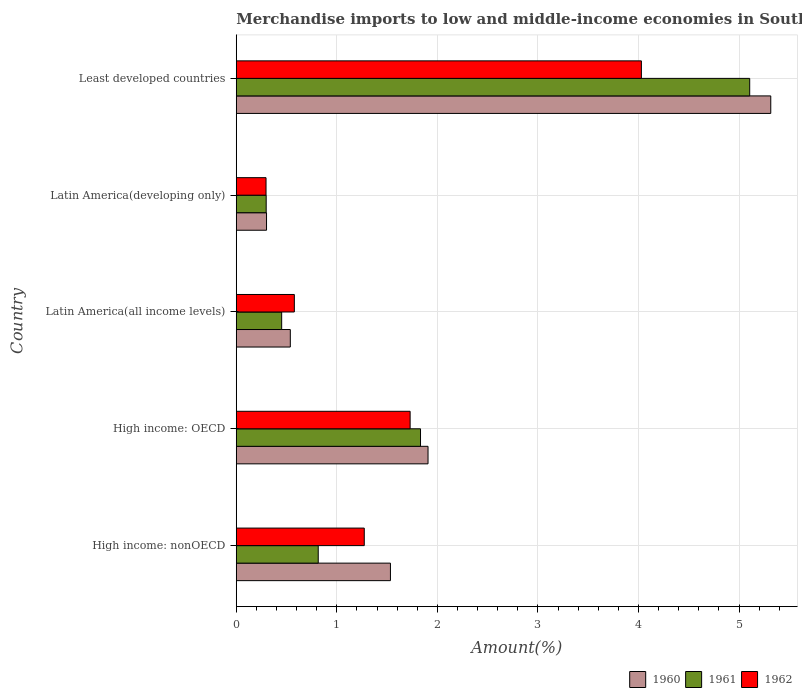How many different coloured bars are there?
Your answer should be compact. 3. Are the number of bars per tick equal to the number of legend labels?
Offer a very short reply. Yes. Are the number of bars on each tick of the Y-axis equal?
Ensure brevity in your answer.  Yes. What is the label of the 1st group of bars from the top?
Make the answer very short. Least developed countries. In how many cases, is the number of bars for a given country not equal to the number of legend labels?
Your response must be concise. 0. What is the percentage of amount earned from merchandise imports in 1961 in Least developed countries?
Provide a succinct answer. 5.11. Across all countries, what is the maximum percentage of amount earned from merchandise imports in 1961?
Make the answer very short. 5.11. Across all countries, what is the minimum percentage of amount earned from merchandise imports in 1962?
Offer a terse response. 0.3. In which country was the percentage of amount earned from merchandise imports in 1962 maximum?
Your answer should be compact. Least developed countries. In which country was the percentage of amount earned from merchandise imports in 1962 minimum?
Your answer should be very brief. Latin America(developing only). What is the total percentage of amount earned from merchandise imports in 1961 in the graph?
Ensure brevity in your answer.  8.5. What is the difference between the percentage of amount earned from merchandise imports in 1961 in High income: OECD and that in Latin America(developing only)?
Your answer should be compact. 1.53. What is the difference between the percentage of amount earned from merchandise imports in 1962 in High income: OECD and the percentage of amount earned from merchandise imports in 1960 in High income: nonOECD?
Keep it short and to the point. 0.2. What is the average percentage of amount earned from merchandise imports in 1961 per country?
Offer a terse response. 1.7. What is the difference between the percentage of amount earned from merchandise imports in 1962 and percentage of amount earned from merchandise imports in 1961 in High income: OECD?
Offer a terse response. -0.1. In how many countries, is the percentage of amount earned from merchandise imports in 1960 greater than 2.2 %?
Provide a succinct answer. 1. What is the ratio of the percentage of amount earned from merchandise imports in 1961 in High income: OECD to that in Least developed countries?
Your answer should be very brief. 0.36. Is the difference between the percentage of amount earned from merchandise imports in 1962 in High income: nonOECD and Latin America(developing only) greater than the difference between the percentage of amount earned from merchandise imports in 1961 in High income: nonOECD and Latin America(developing only)?
Provide a succinct answer. Yes. What is the difference between the highest and the second highest percentage of amount earned from merchandise imports in 1961?
Ensure brevity in your answer.  3.27. What is the difference between the highest and the lowest percentage of amount earned from merchandise imports in 1960?
Offer a terse response. 5.01. In how many countries, is the percentage of amount earned from merchandise imports in 1960 greater than the average percentage of amount earned from merchandise imports in 1960 taken over all countries?
Provide a short and direct response. 1. Is the sum of the percentage of amount earned from merchandise imports in 1961 in High income: OECD and Least developed countries greater than the maximum percentage of amount earned from merchandise imports in 1962 across all countries?
Offer a terse response. Yes. What does the 3rd bar from the top in Least developed countries represents?
Ensure brevity in your answer.  1960. Is it the case that in every country, the sum of the percentage of amount earned from merchandise imports in 1962 and percentage of amount earned from merchandise imports in 1961 is greater than the percentage of amount earned from merchandise imports in 1960?
Provide a succinct answer. Yes. How many bars are there?
Your answer should be very brief. 15. Are all the bars in the graph horizontal?
Your response must be concise. Yes. What is the difference between two consecutive major ticks on the X-axis?
Ensure brevity in your answer.  1. Are the values on the major ticks of X-axis written in scientific E-notation?
Keep it short and to the point. No. How are the legend labels stacked?
Provide a short and direct response. Horizontal. What is the title of the graph?
Make the answer very short. Merchandise imports to low and middle-income economies in South Asia. What is the label or title of the X-axis?
Your answer should be very brief. Amount(%). What is the label or title of the Y-axis?
Offer a very short reply. Country. What is the Amount(%) of 1960 in High income: nonOECD?
Make the answer very short. 1.53. What is the Amount(%) in 1961 in High income: nonOECD?
Your answer should be compact. 0.82. What is the Amount(%) of 1962 in High income: nonOECD?
Give a very brief answer. 1.27. What is the Amount(%) of 1960 in High income: OECD?
Keep it short and to the point. 1.91. What is the Amount(%) in 1961 in High income: OECD?
Offer a terse response. 1.83. What is the Amount(%) of 1962 in High income: OECD?
Make the answer very short. 1.73. What is the Amount(%) of 1960 in Latin America(all income levels)?
Provide a succinct answer. 0.54. What is the Amount(%) of 1961 in Latin America(all income levels)?
Keep it short and to the point. 0.45. What is the Amount(%) in 1962 in Latin America(all income levels)?
Keep it short and to the point. 0.58. What is the Amount(%) in 1960 in Latin America(developing only)?
Provide a succinct answer. 0.3. What is the Amount(%) in 1961 in Latin America(developing only)?
Provide a succinct answer. 0.3. What is the Amount(%) of 1962 in Latin America(developing only)?
Keep it short and to the point. 0.3. What is the Amount(%) of 1960 in Least developed countries?
Offer a very short reply. 5.32. What is the Amount(%) of 1961 in Least developed countries?
Give a very brief answer. 5.11. What is the Amount(%) of 1962 in Least developed countries?
Keep it short and to the point. 4.03. Across all countries, what is the maximum Amount(%) in 1960?
Offer a terse response. 5.32. Across all countries, what is the maximum Amount(%) in 1961?
Your answer should be compact. 5.11. Across all countries, what is the maximum Amount(%) in 1962?
Your answer should be very brief. 4.03. Across all countries, what is the minimum Amount(%) in 1960?
Your answer should be very brief. 0.3. Across all countries, what is the minimum Amount(%) of 1961?
Make the answer very short. 0.3. Across all countries, what is the minimum Amount(%) in 1962?
Your answer should be compact. 0.3. What is the total Amount(%) in 1960 in the graph?
Your answer should be very brief. 9.59. What is the total Amount(%) in 1961 in the graph?
Provide a succinct answer. 8.5. What is the total Amount(%) of 1962 in the graph?
Provide a succinct answer. 7.9. What is the difference between the Amount(%) of 1960 in High income: nonOECD and that in High income: OECD?
Offer a very short reply. -0.37. What is the difference between the Amount(%) of 1961 in High income: nonOECD and that in High income: OECD?
Ensure brevity in your answer.  -1.02. What is the difference between the Amount(%) of 1962 in High income: nonOECD and that in High income: OECD?
Your response must be concise. -0.46. What is the difference between the Amount(%) in 1961 in High income: nonOECD and that in Latin America(all income levels)?
Provide a short and direct response. 0.36. What is the difference between the Amount(%) in 1962 in High income: nonOECD and that in Latin America(all income levels)?
Your answer should be very brief. 0.7. What is the difference between the Amount(%) in 1960 in High income: nonOECD and that in Latin America(developing only)?
Provide a succinct answer. 1.23. What is the difference between the Amount(%) of 1961 in High income: nonOECD and that in Latin America(developing only)?
Provide a succinct answer. 0.52. What is the difference between the Amount(%) of 1962 in High income: nonOECD and that in Latin America(developing only)?
Offer a terse response. 0.98. What is the difference between the Amount(%) in 1960 in High income: nonOECD and that in Least developed countries?
Offer a terse response. -3.78. What is the difference between the Amount(%) of 1961 in High income: nonOECD and that in Least developed countries?
Your answer should be very brief. -4.29. What is the difference between the Amount(%) in 1962 in High income: nonOECD and that in Least developed countries?
Your answer should be compact. -2.76. What is the difference between the Amount(%) in 1960 in High income: OECD and that in Latin America(all income levels)?
Provide a short and direct response. 1.37. What is the difference between the Amount(%) of 1961 in High income: OECD and that in Latin America(all income levels)?
Your answer should be very brief. 1.38. What is the difference between the Amount(%) in 1962 in High income: OECD and that in Latin America(all income levels)?
Provide a succinct answer. 1.15. What is the difference between the Amount(%) of 1960 in High income: OECD and that in Latin America(developing only)?
Ensure brevity in your answer.  1.61. What is the difference between the Amount(%) in 1961 in High income: OECD and that in Latin America(developing only)?
Ensure brevity in your answer.  1.53. What is the difference between the Amount(%) in 1962 in High income: OECD and that in Latin America(developing only)?
Provide a short and direct response. 1.43. What is the difference between the Amount(%) of 1960 in High income: OECD and that in Least developed countries?
Give a very brief answer. -3.41. What is the difference between the Amount(%) of 1961 in High income: OECD and that in Least developed countries?
Ensure brevity in your answer.  -3.27. What is the difference between the Amount(%) of 1962 in High income: OECD and that in Least developed countries?
Offer a terse response. -2.3. What is the difference between the Amount(%) in 1960 in Latin America(all income levels) and that in Latin America(developing only)?
Offer a terse response. 0.24. What is the difference between the Amount(%) of 1961 in Latin America(all income levels) and that in Latin America(developing only)?
Ensure brevity in your answer.  0.15. What is the difference between the Amount(%) in 1962 in Latin America(all income levels) and that in Latin America(developing only)?
Your response must be concise. 0.28. What is the difference between the Amount(%) in 1960 in Latin America(all income levels) and that in Least developed countries?
Give a very brief answer. -4.78. What is the difference between the Amount(%) of 1961 in Latin America(all income levels) and that in Least developed countries?
Keep it short and to the point. -4.65. What is the difference between the Amount(%) of 1962 in Latin America(all income levels) and that in Least developed countries?
Provide a short and direct response. -3.45. What is the difference between the Amount(%) of 1960 in Latin America(developing only) and that in Least developed countries?
Your answer should be very brief. -5.01. What is the difference between the Amount(%) of 1961 in Latin America(developing only) and that in Least developed countries?
Make the answer very short. -4.81. What is the difference between the Amount(%) in 1962 in Latin America(developing only) and that in Least developed countries?
Your answer should be compact. -3.73. What is the difference between the Amount(%) of 1960 in High income: nonOECD and the Amount(%) of 1961 in High income: OECD?
Offer a very short reply. -0.3. What is the difference between the Amount(%) in 1960 in High income: nonOECD and the Amount(%) in 1962 in High income: OECD?
Give a very brief answer. -0.2. What is the difference between the Amount(%) in 1961 in High income: nonOECD and the Amount(%) in 1962 in High income: OECD?
Your answer should be very brief. -0.91. What is the difference between the Amount(%) in 1960 in High income: nonOECD and the Amount(%) in 1961 in Latin America(all income levels)?
Offer a very short reply. 1.08. What is the difference between the Amount(%) in 1960 in High income: nonOECD and the Amount(%) in 1962 in Latin America(all income levels)?
Offer a very short reply. 0.96. What is the difference between the Amount(%) in 1961 in High income: nonOECD and the Amount(%) in 1962 in Latin America(all income levels)?
Your response must be concise. 0.24. What is the difference between the Amount(%) in 1960 in High income: nonOECD and the Amount(%) in 1961 in Latin America(developing only)?
Give a very brief answer. 1.24. What is the difference between the Amount(%) in 1960 in High income: nonOECD and the Amount(%) in 1962 in Latin America(developing only)?
Your answer should be compact. 1.24. What is the difference between the Amount(%) in 1961 in High income: nonOECD and the Amount(%) in 1962 in Latin America(developing only)?
Keep it short and to the point. 0.52. What is the difference between the Amount(%) in 1960 in High income: nonOECD and the Amount(%) in 1961 in Least developed countries?
Ensure brevity in your answer.  -3.57. What is the difference between the Amount(%) in 1960 in High income: nonOECD and the Amount(%) in 1962 in Least developed countries?
Make the answer very short. -2.5. What is the difference between the Amount(%) of 1961 in High income: nonOECD and the Amount(%) of 1962 in Least developed countries?
Provide a short and direct response. -3.21. What is the difference between the Amount(%) of 1960 in High income: OECD and the Amount(%) of 1961 in Latin America(all income levels)?
Your answer should be compact. 1.46. What is the difference between the Amount(%) of 1960 in High income: OECD and the Amount(%) of 1962 in Latin America(all income levels)?
Give a very brief answer. 1.33. What is the difference between the Amount(%) of 1961 in High income: OECD and the Amount(%) of 1962 in Latin America(all income levels)?
Offer a terse response. 1.25. What is the difference between the Amount(%) in 1960 in High income: OECD and the Amount(%) in 1961 in Latin America(developing only)?
Keep it short and to the point. 1.61. What is the difference between the Amount(%) of 1960 in High income: OECD and the Amount(%) of 1962 in Latin America(developing only)?
Offer a terse response. 1.61. What is the difference between the Amount(%) in 1961 in High income: OECD and the Amount(%) in 1962 in Latin America(developing only)?
Offer a terse response. 1.54. What is the difference between the Amount(%) of 1960 in High income: OECD and the Amount(%) of 1961 in Least developed countries?
Make the answer very short. -3.2. What is the difference between the Amount(%) of 1960 in High income: OECD and the Amount(%) of 1962 in Least developed countries?
Provide a succinct answer. -2.12. What is the difference between the Amount(%) of 1961 in High income: OECD and the Amount(%) of 1962 in Least developed countries?
Your answer should be compact. -2.2. What is the difference between the Amount(%) in 1960 in Latin America(all income levels) and the Amount(%) in 1961 in Latin America(developing only)?
Provide a short and direct response. 0.24. What is the difference between the Amount(%) in 1960 in Latin America(all income levels) and the Amount(%) in 1962 in Latin America(developing only)?
Give a very brief answer. 0.24. What is the difference between the Amount(%) in 1961 in Latin America(all income levels) and the Amount(%) in 1962 in Latin America(developing only)?
Provide a short and direct response. 0.16. What is the difference between the Amount(%) of 1960 in Latin America(all income levels) and the Amount(%) of 1961 in Least developed countries?
Offer a terse response. -4.57. What is the difference between the Amount(%) in 1960 in Latin America(all income levels) and the Amount(%) in 1962 in Least developed countries?
Ensure brevity in your answer.  -3.49. What is the difference between the Amount(%) of 1961 in Latin America(all income levels) and the Amount(%) of 1962 in Least developed countries?
Offer a terse response. -3.58. What is the difference between the Amount(%) of 1960 in Latin America(developing only) and the Amount(%) of 1961 in Least developed countries?
Your response must be concise. -4.8. What is the difference between the Amount(%) of 1960 in Latin America(developing only) and the Amount(%) of 1962 in Least developed countries?
Make the answer very short. -3.73. What is the difference between the Amount(%) of 1961 in Latin America(developing only) and the Amount(%) of 1962 in Least developed countries?
Your answer should be compact. -3.73. What is the average Amount(%) in 1960 per country?
Offer a very short reply. 1.92. What is the average Amount(%) of 1961 per country?
Ensure brevity in your answer.  1.7. What is the average Amount(%) in 1962 per country?
Your answer should be very brief. 1.58. What is the difference between the Amount(%) in 1960 and Amount(%) in 1961 in High income: nonOECD?
Provide a succinct answer. 0.72. What is the difference between the Amount(%) of 1960 and Amount(%) of 1962 in High income: nonOECD?
Provide a succinct answer. 0.26. What is the difference between the Amount(%) in 1961 and Amount(%) in 1962 in High income: nonOECD?
Provide a short and direct response. -0.46. What is the difference between the Amount(%) in 1960 and Amount(%) in 1961 in High income: OECD?
Ensure brevity in your answer.  0.07. What is the difference between the Amount(%) in 1960 and Amount(%) in 1962 in High income: OECD?
Provide a succinct answer. 0.18. What is the difference between the Amount(%) in 1961 and Amount(%) in 1962 in High income: OECD?
Provide a succinct answer. 0.1. What is the difference between the Amount(%) of 1960 and Amount(%) of 1961 in Latin America(all income levels)?
Keep it short and to the point. 0.09. What is the difference between the Amount(%) in 1960 and Amount(%) in 1962 in Latin America(all income levels)?
Give a very brief answer. -0.04. What is the difference between the Amount(%) of 1961 and Amount(%) of 1962 in Latin America(all income levels)?
Offer a terse response. -0.13. What is the difference between the Amount(%) in 1960 and Amount(%) in 1961 in Latin America(developing only)?
Ensure brevity in your answer.  0. What is the difference between the Amount(%) of 1960 and Amount(%) of 1962 in Latin America(developing only)?
Offer a terse response. 0.01. What is the difference between the Amount(%) in 1961 and Amount(%) in 1962 in Latin America(developing only)?
Offer a terse response. 0. What is the difference between the Amount(%) of 1960 and Amount(%) of 1961 in Least developed countries?
Give a very brief answer. 0.21. What is the difference between the Amount(%) of 1960 and Amount(%) of 1962 in Least developed countries?
Your answer should be compact. 1.29. What is the difference between the Amount(%) in 1961 and Amount(%) in 1962 in Least developed countries?
Keep it short and to the point. 1.08. What is the ratio of the Amount(%) in 1960 in High income: nonOECD to that in High income: OECD?
Keep it short and to the point. 0.8. What is the ratio of the Amount(%) in 1961 in High income: nonOECD to that in High income: OECD?
Give a very brief answer. 0.44. What is the ratio of the Amount(%) of 1962 in High income: nonOECD to that in High income: OECD?
Your response must be concise. 0.74. What is the ratio of the Amount(%) in 1960 in High income: nonOECD to that in Latin America(all income levels)?
Keep it short and to the point. 2.85. What is the ratio of the Amount(%) of 1961 in High income: nonOECD to that in Latin America(all income levels)?
Your answer should be compact. 1.81. What is the ratio of the Amount(%) of 1962 in High income: nonOECD to that in Latin America(all income levels)?
Offer a very short reply. 2.2. What is the ratio of the Amount(%) in 1960 in High income: nonOECD to that in Latin America(developing only)?
Provide a succinct answer. 5.09. What is the ratio of the Amount(%) of 1961 in High income: nonOECD to that in Latin America(developing only)?
Make the answer very short. 2.74. What is the ratio of the Amount(%) in 1962 in High income: nonOECD to that in Latin America(developing only)?
Keep it short and to the point. 4.3. What is the ratio of the Amount(%) of 1960 in High income: nonOECD to that in Least developed countries?
Offer a terse response. 0.29. What is the ratio of the Amount(%) in 1961 in High income: nonOECD to that in Least developed countries?
Provide a short and direct response. 0.16. What is the ratio of the Amount(%) in 1962 in High income: nonOECD to that in Least developed countries?
Your answer should be compact. 0.32. What is the ratio of the Amount(%) of 1960 in High income: OECD to that in Latin America(all income levels)?
Offer a terse response. 3.55. What is the ratio of the Amount(%) in 1961 in High income: OECD to that in Latin America(all income levels)?
Offer a terse response. 4.06. What is the ratio of the Amount(%) of 1962 in High income: OECD to that in Latin America(all income levels)?
Your answer should be very brief. 2.99. What is the ratio of the Amount(%) of 1960 in High income: OECD to that in Latin America(developing only)?
Ensure brevity in your answer.  6.33. What is the ratio of the Amount(%) of 1961 in High income: OECD to that in Latin America(developing only)?
Provide a succinct answer. 6.16. What is the ratio of the Amount(%) of 1962 in High income: OECD to that in Latin America(developing only)?
Provide a short and direct response. 5.84. What is the ratio of the Amount(%) in 1960 in High income: OECD to that in Least developed countries?
Provide a succinct answer. 0.36. What is the ratio of the Amount(%) of 1961 in High income: OECD to that in Least developed countries?
Make the answer very short. 0.36. What is the ratio of the Amount(%) of 1962 in High income: OECD to that in Least developed countries?
Make the answer very short. 0.43. What is the ratio of the Amount(%) in 1960 in Latin America(all income levels) to that in Latin America(developing only)?
Make the answer very short. 1.78. What is the ratio of the Amount(%) of 1961 in Latin America(all income levels) to that in Latin America(developing only)?
Provide a short and direct response. 1.52. What is the ratio of the Amount(%) of 1962 in Latin America(all income levels) to that in Latin America(developing only)?
Offer a very short reply. 1.95. What is the ratio of the Amount(%) in 1960 in Latin America(all income levels) to that in Least developed countries?
Keep it short and to the point. 0.1. What is the ratio of the Amount(%) of 1961 in Latin America(all income levels) to that in Least developed countries?
Provide a succinct answer. 0.09. What is the ratio of the Amount(%) in 1962 in Latin America(all income levels) to that in Least developed countries?
Offer a very short reply. 0.14. What is the ratio of the Amount(%) in 1960 in Latin America(developing only) to that in Least developed countries?
Your response must be concise. 0.06. What is the ratio of the Amount(%) in 1961 in Latin America(developing only) to that in Least developed countries?
Keep it short and to the point. 0.06. What is the ratio of the Amount(%) of 1962 in Latin America(developing only) to that in Least developed countries?
Keep it short and to the point. 0.07. What is the difference between the highest and the second highest Amount(%) of 1960?
Offer a terse response. 3.41. What is the difference between the highest and the second highest Amount(%) of 1961?
Offer a terse response. 3.27. What is the difference between the highest and the second highest Amount(%) of 1962?
Offer a very short reply. 2.3. What is the difference between the highest and the lowest Amount(%) of 1960?
Give a very brief answer. 5.01. What is the difference between the highest and the lowest Amount(%) of 1961?
Your response must be concise. 4.81. What is the difference between the highest and the lowest Amount(%) of 1962?
Your answer should be very brief. 3.73. 